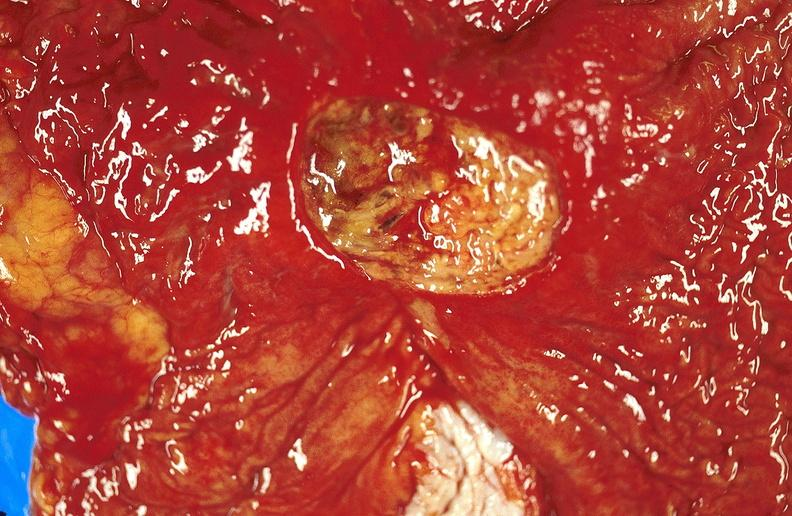what is present?
Answer the question using a single word or phrase. Gastrointestinal 